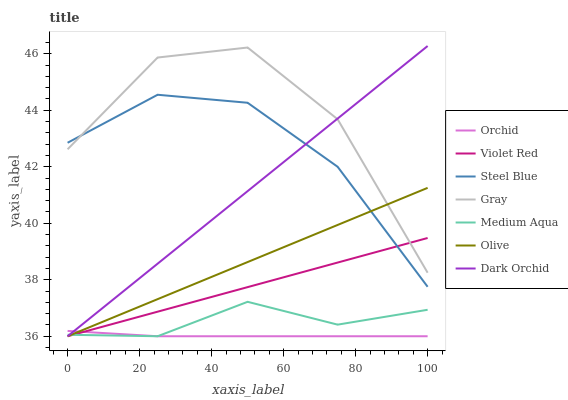Does Orchid have the minimum area under the curve?
Answer yes or no. Yes. Does Gray have the maximum area under the curve?
Answer yes or no. Yes. Does Violet Red have the minimum area under the curve?
Answer yes or no. No. Does Violet Red have the maximum area under the curve?
Answer yes or no. No. Is Olive the smoothest?
Answer yes or no. Yes. Is Gray the roughest?
Answer yes or no. Yes. Is Violet Red the smoothest?
Answer yes or no. No. Is Violet Red the roughest?
Answer yes or no. No. Does Violet Red have the lowest value?
Answer yes or no. Yes. Does Steel Blue have the lowest value?
Answer yes or no. No. Does Dark Orchid have the highest value?
Answer yes or no. Yes. Does Violet Red have the highest value?
Answer yes or no. No. Is Orchid less than Gray?
Answer yes or no. Yes. Is Gray greater than Orchid?
Answer yes or no. Yes. Does Orchid intersect Dark Orchid?
Answer yes or no. Yes. Is Orchid less than Dark Orchid?
Answer yes or no. No. Is Orchid greater than Dark Orchid?
Answer yes or no. No. Does Orchid intersect Gray?
Answer yes or no. No. 